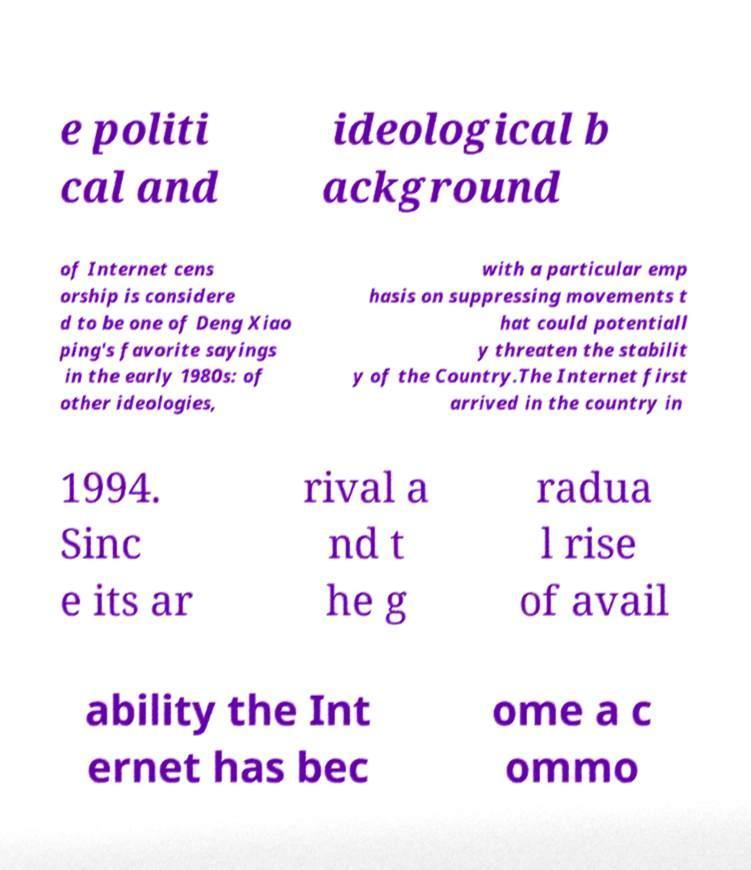Please identify and transcribe the text found in this image. e politi cal and ideological b ackground of Internet cens orship is considere d to be one of Deng Xiao ping's favorite sayings in the early 1980s: of other ideologies, with a particular emp hasis on suppressing movements t hat could potentiall y threaten the stabilit y of the Country.The Internet first arrived in the country in 1994. Sinc e its ar rival a nd t he g radua l rise of avail ability the Int ernet has bec ome a c ommo 